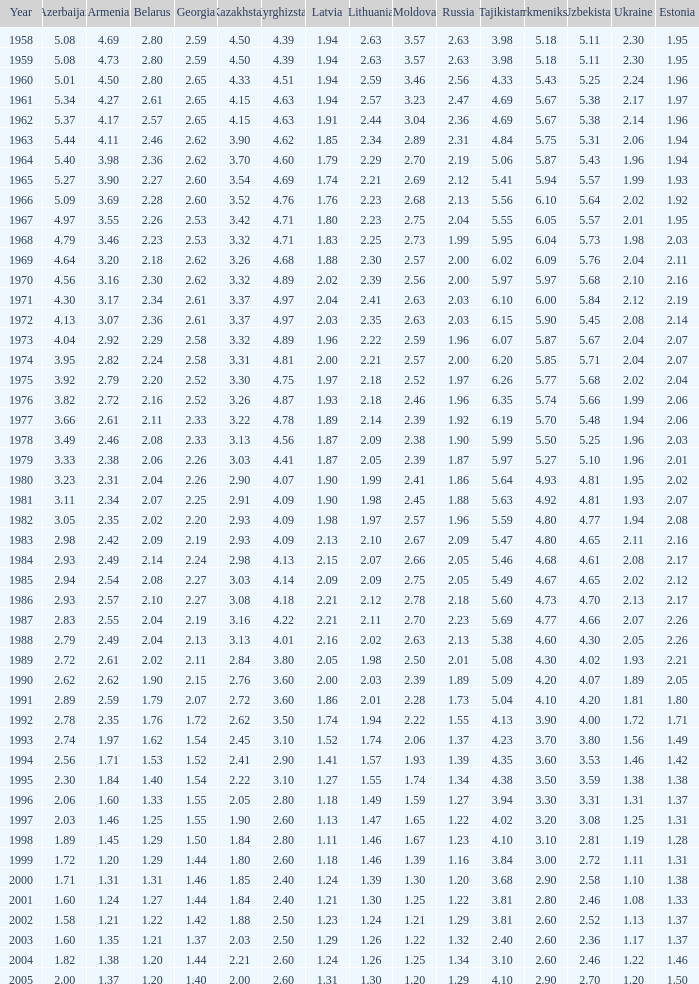62 and belarus beneath None. 